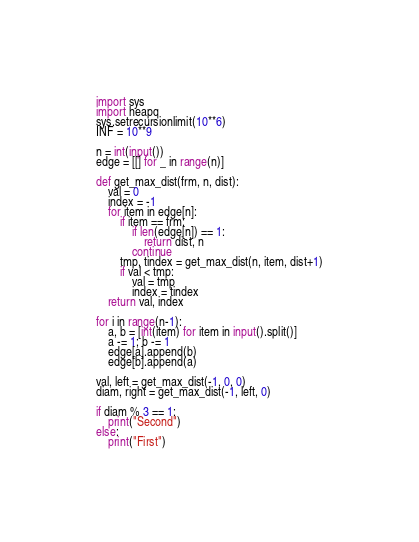<code> <loc_0><loc_0><loc_500><loc_500><_Python_>import sys
import heapq
sys.setrecursionlimit(10**6)
INF = 10**9

n = int(input())
edge = [[] for _ in range(n)]

def get_max_dist(frm, n, dist):
    val = 0
    index = -1
    for item in edge[n]:
        if item == frm:
            if len(edge[n]) == 1:
                return dist, n
            continue
        tmp, tindex = get_max_dist(n, item, dist+1)
        if val < tmp:
            val = tmp
            index = tindex
    return val, index

for i in range(n-1):
    a, b = [int(item) for item in input().split()]
    a -= 1; b -= 1
    edge[a].append(b)
    edge[b].append(a)

val, left = get_max_dist(-1, 0, 0)
diam, right = get_max_dist(-1, left, 0)

if diam % 3 == 1:
    print("Second")
else:
    print("First")</code> 